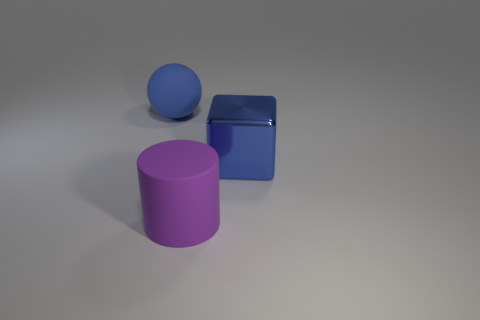What is the shape of the metal object that is the same color as the sphere?
Provide a short and direct response. Cube. Are any cylinders visible?
Your answer should be compact. Yes. What is the size of the blue thing that is made of the same material as the purple cylinder?
Offer a very short reply. Large. The large blue object that is to the right of the large blue object that is behind the large blue thing in front of the blue matte sphere is what shape?
Your response must be concise. Cube. Are there the same number of purple things on the right side of the large purple rubber thing and large blue metal objects?
Offer a very short reply. No. What size is the object that is the same color as the big metallic block?
Offer a very short reply. Large. Do the metallic object and the purple object have the same shape?
Keep it short and to the point. No. How many objects are things that are left of the large blue cube or blue rubber balls?
Your answer should be compact. 2. Are there an equal number of big blue balls that are behind the big rubber cylinder and blue balls behind the blue sphere?
Provide a succinct answer. No. How many other things are the same shape as the purple matte thing?
Make the answer very short. 0. 